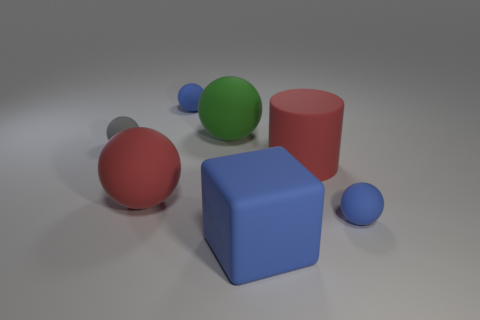Subtract all red spheres. How many spheres are left? 4 Subtract all gray matte balls. How many balls are left? 4 Subtract all brown balls. Subtract all cyan cylinders. How many balls are left? 5 Add 1 large cyan metallic spheres. How many objects exist? 8 Subtract all spheres. How many objects are left? 2 Add 3 green blocks. How many green blocks exist? 3 Subtract 0 brown cylinders. How many objects are left? 7 Subtract all big blue rubber blocks. Subtract all blue spheres. How many objects are left? 4 Add 4 rubber balls. How many rubber balls are left? 9 